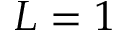Convert formula to latex. <formula><loc_0><loc_0><loc_500><loc_500>L = 1</formula> 